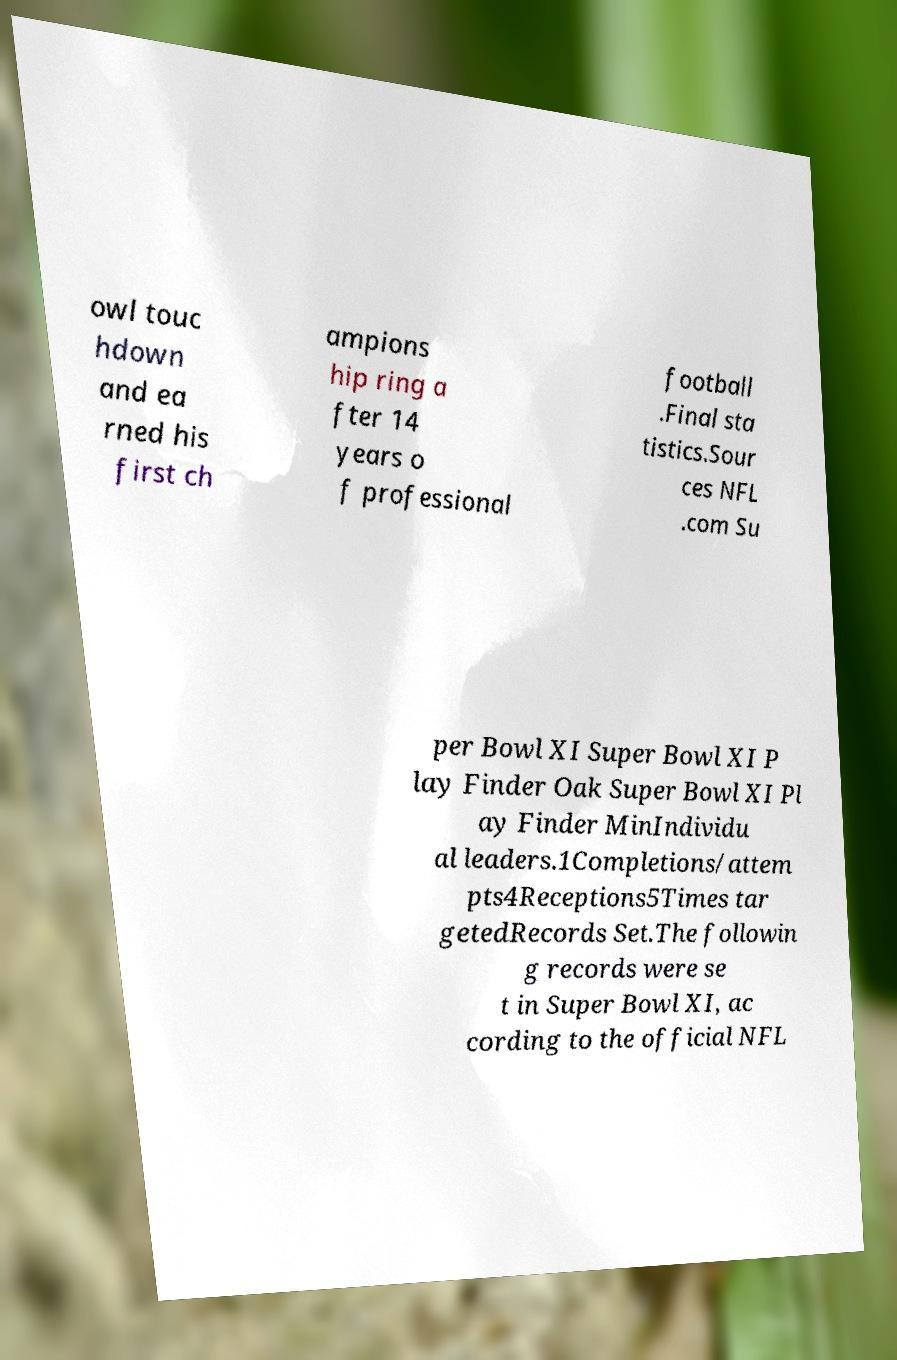What messages or text are displayed in this image? I need them in a readable, typed format. owl touc hdown and ea rned his first ch ampions hip ring a fter 14 years o f professional football .Final sta tistics.Sour ces NFL .com Su per Bowl XI Super Bowl XI P lay Finder Oak Super Bowl XI Pl ay Finder MinIndividu al leaders.1Completions/attem pts4Receptions5Times tar getedRecords Set.The followin g records were se t in Super Bowl XI, ac cording to the official NFL 